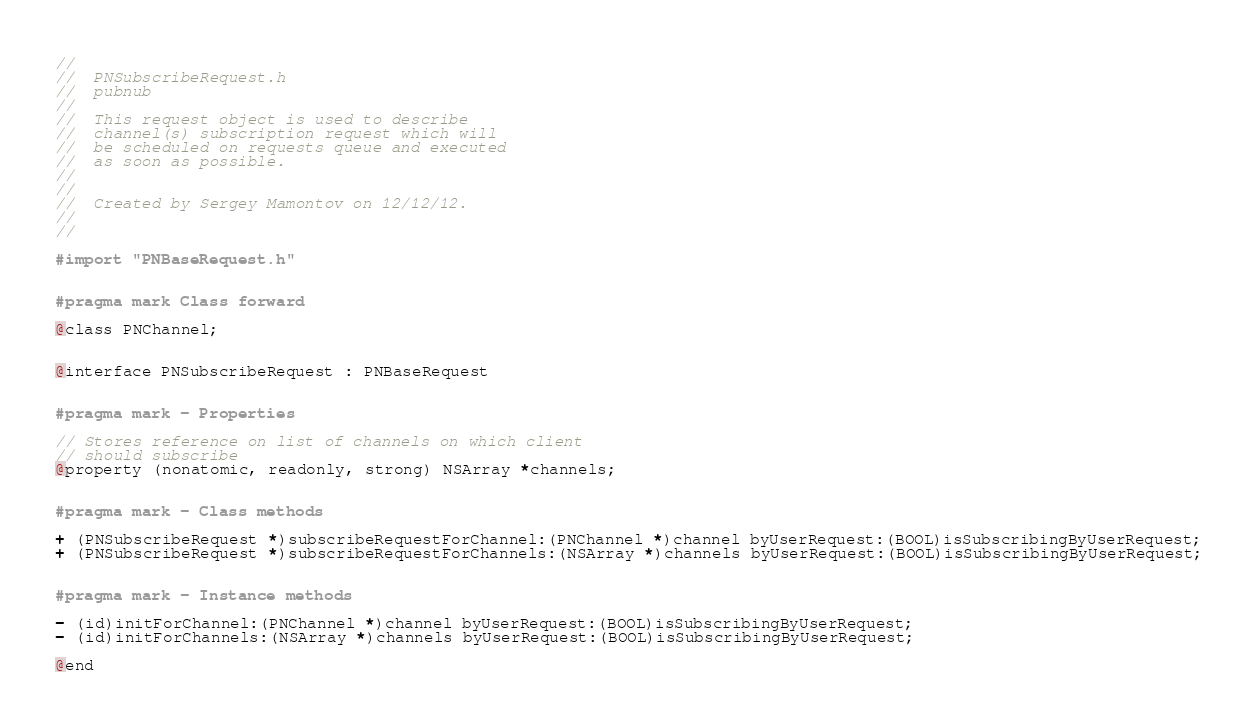Convert code to text. <code><loc_0><loc_0><loc_500><loc_500><_C_>//
//  PNSubscribeRequest.h
//  pubnub
//
//  This request object is used to describe
//  channel(s) subscription request which will
//  be scheduled on requests queue and executed
//  as soon as possible.
//
//
//  Created by Sergey Mamontov on 12/12/12.
//
//

#import "PNBaseRequest.h"


#pragma mark Class forward

@class PNChannel;


@interface PNSubscribeRequest : PNBaseRequest


#pragma mark - Properties

// Stores reference on list of channels on which client
// should subscribe
@property (nonatomic, readonly, strong) NSArray *channels;


#pragma mark - Class methods

+ (PNSubscribeRequest *)subscribeRequestForChannel:(PNChannel *)channel byUserRequest:(BOOL)isSubscribingByUserRequest;
+ (PNSubscribeRequest *)subscribeRequestForChannels:(NSArray *)channels byUserRequest:(BOOL)isSubscribingByUserRequest;


#pragma mark - Instance methods

- (id)initForChannel:(PNChannel *)channel byUserRequest:(BOOL)isSubscribingByUserRequest;
- (id)initForChannels:(NSArray *)channels byUserRequest:(BOOL)isSubscribingByUserRequest;

@end
</code> 